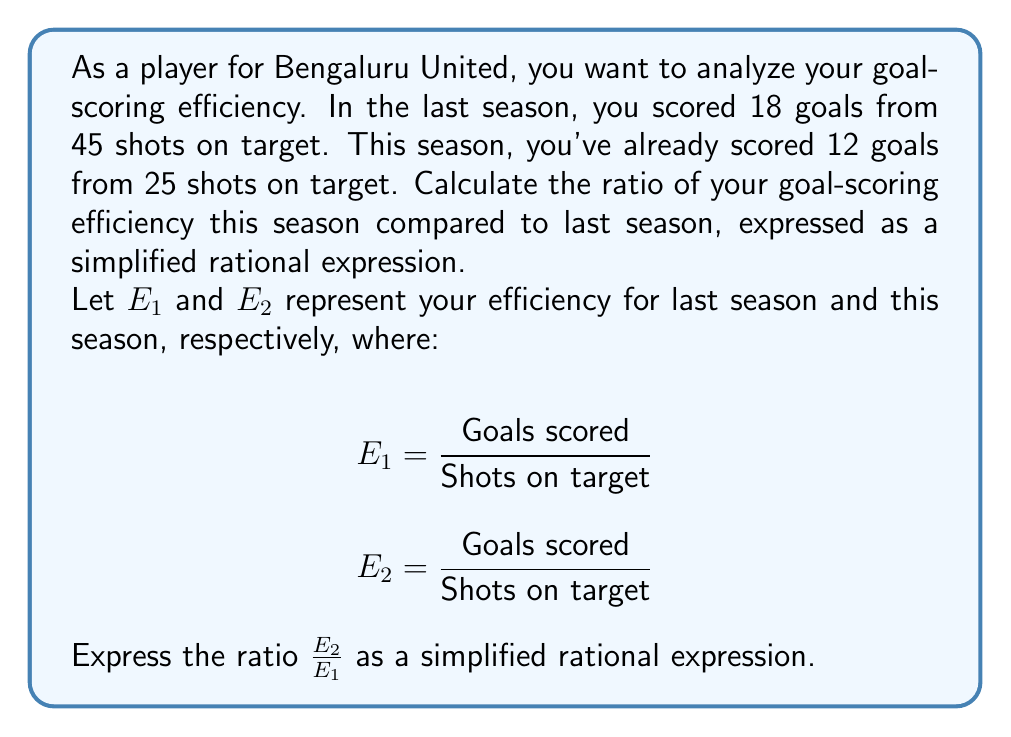Help me with this question. Let's solve this step-by-step:

1) First, calculate the efficiency for last season ($E_1$):
   $$E_1 = \frac{18}{45} = \frac{2}{5}$$

2) Now, calculate the efficiency for this season ($E_2$):
   $$E_2 = \frac{12}{25}$$

3) To compare the efficiencies, we need to calculate $\frac{E_2}{E_1}$:
   $$\frac{E_2}{E_1} = \frac{\frac{12}{25}}{\frac{2}{5}}$$

4) When dividing fractions, we multiply by the reciprocal:
   $$\frac{E_2}{E_1} = \frac{12}{25} \cdot \frac{5}{2}$$

5) Multiply the numerators and denominators:
   $$\frac{E_2}{E_1} = \frac{12 \cdot 5}{25 \cdot 2} = \frac{60}{50}$$

6) Simplify by dividing both numerator and denominator by their greatest common divisor (10):
   $$\frac{E_2}{E_1} = \frac{60 \div 10}{50 \div 10} = \frac{6}{5}$$

Therefore, the ratio of your goal-scoring efficiency this season compared to last season is $\frac{6}{5}$.
Answer: $\frac{6}{5}$ 